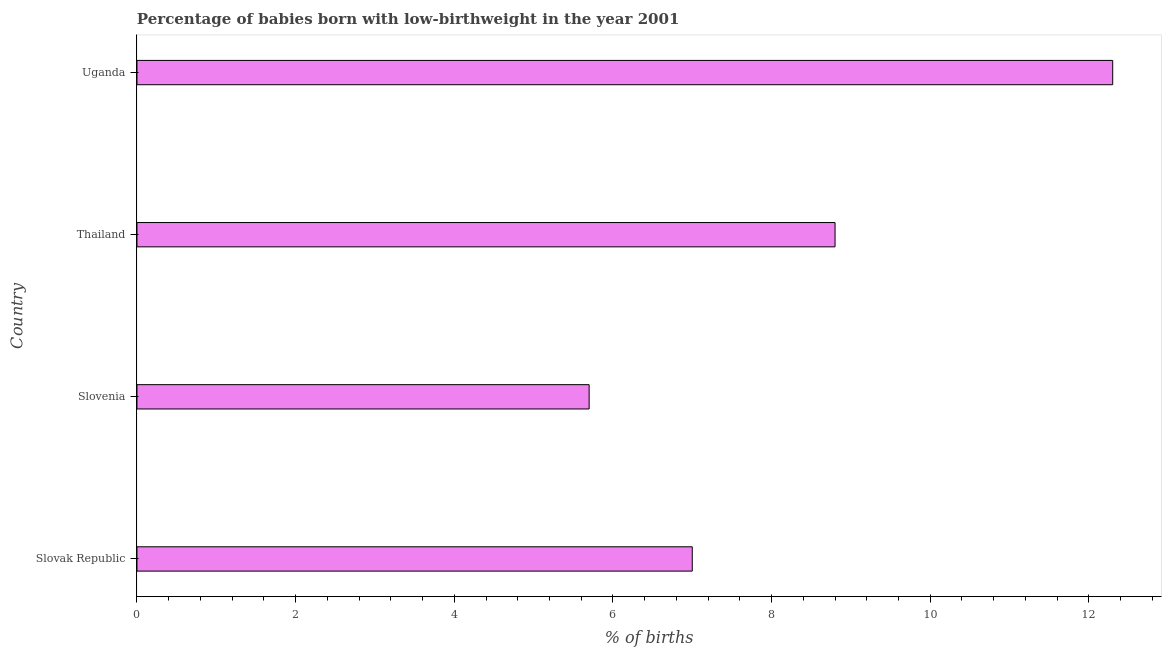Does the graph contain any zero values?
Ensure brevity in your answer.  No. What is the title of the graph?
Give a very brief answer. Percentage of babies born with low-birthweight in the year 2001. What is the label or title of the X-axis?
Provide a short and direct response. % of births. What is the percentage of babies who were born with low-birthweight in Thailand?
Make the answer very short. 8.8. Across all countries, what is the minimum percentage of babies who were born with low-birthweight?
Your response must be concise. 5.7. In which country was the percentage of babies who were born with low-birthweight maximum?
Keep it short and to the point. Uganda. In which country was the percentage of babies who were born with low-birthweight minimum?
Your answer should be very brief. Slovenia. What is the sum of the percentage of babies who were born with low-birthweight?
Keep it short and to the point. 33.8. What is the difference between the percentage of babies who were born with low-birthweight in Thailand and Uganda?
Give a very brief answer. -3.5. What is the average percentage of babies who were born with low-birthweight per country?
Your answer should be very brief. 8.45. What is the median percentage of babies who were born with low-birthweight?
Your response must be concise. 7.9. What is the ratio of the percentage of babies who were born with low-birthweight in Thailand to that in Uganda?
Your answer should be very brief. 0.71. Is the percentage of babies who were born with low-birthweight in Thailand less than that in Uganda?
Make the answer very short. Yes. What is the difference between the highest and the second highest percentage of babies who were born with low-birthweight?
Provide a short and direct response. 3.5. Is the sum of the percentage of babies who were born with low-birthweight in Thailand and Uganda greater than the maximum percentage of babies who were born with low-birthweight across all countries?
Offer a very short reply. Yes. In how many countries, is the percentage of babies who were born with low-birthweight greater than the average percentage of babies who were born with low-birthweight taken over all countries?
Your response must be concise. 2. Are all the bars in the graph horizontal?
Ensure brevity in your answer.  Yes. How many countries are there in the graph?
Provide a short and direct response. 4. What is the % of births in Slovak Republic?
Your answer should be very brief. 7. What is the % of births of Slovenia?
Your answer should be very brief. 5.7. What is the % of births in Thailand?
Keep it short and to the point. 8.8. What is the % of births of Uganda?
Your response must be concise. 12.3. What is the difference between the % of births in Slovak Republic and Slovenia?
Give a very brief answer. 1.3. What is the difference between the % of births in Slovak Republic and Uganda?
Your answer should be very brief. -5.3. What is the difference between the % of births in Slovenia and Uganda?
Your answer should be very brief. -6.6. What is the difference between the % of births in Thailand and Uganda?
Offer a very short reply. -3.5. What is the ratio of the % of births in Slovak Republic to that in Slovenia?
Make the answer very short. 1.23. What is the ratio of the % of births in Slovak Republic to that in Thailand?
Make the answer very short. 0.8. What is the ratio of the % of births in Slovak Republic to that in Uganda?
Offer a terse response. 0.57. What is the ratio of the % of births in Slovenia to that in Thailand?
Your answer should be very brief. 0.65. What is the ratio of the % of births in Slovenia to that in Uganda?
Keep it short and to the point. 0.46. What is the ratio of the % of births in Thailand to that in Uganda?
Make the answer very short. 0.71. 